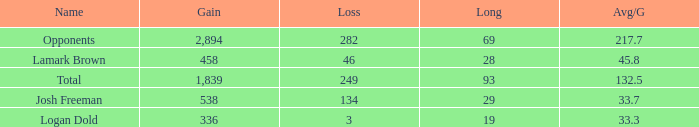Which Long is the highest one that has a Loss larger than 3, and a Gain larger than 2,894? None. 